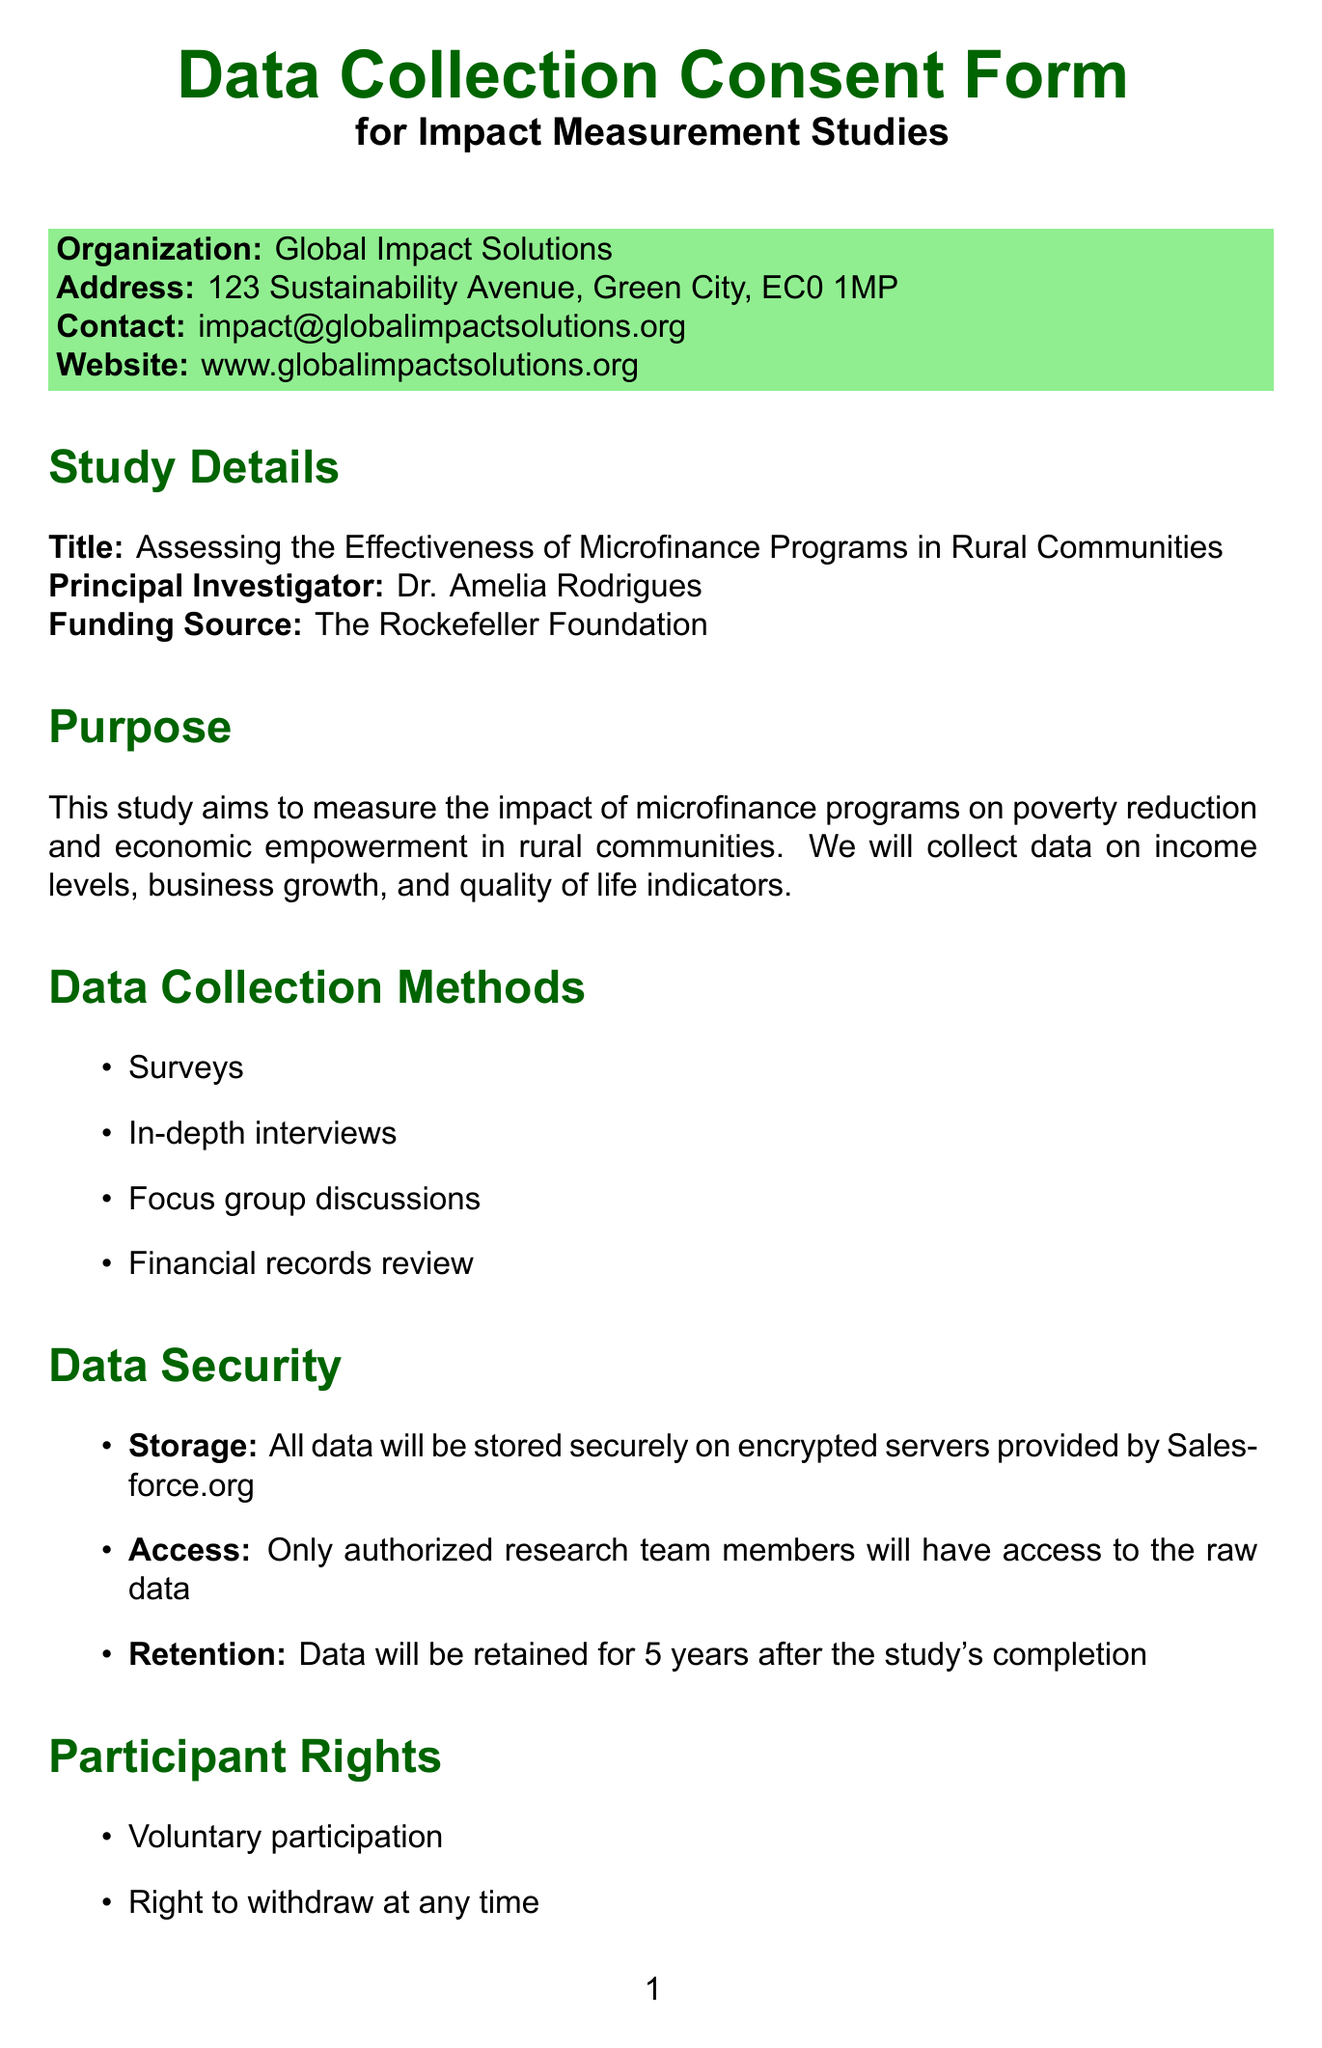what is the title of the study? The title of the study is listed in the document under Study Details.
Answer: Assessing the Effectiveness of Microfinance Programs in Rural Communities who is the principal investigator? The principal investigator is identified in the Study Details section of the document.
Answer: Dr. Amelia Rodrigues how long will data be retained after the study's completion? The data retention period is mentioned under Data Security.
Answer: 5 years what methods will be used for data collection? The data collection methods are specified in a list under Data Collection Methods.
Answer: Surveys, In-depth interviews, Focus group discussions, Financial records review what is the purpose of sharing data with partners? The purpose of data sharing is explained in the Data Sharing section.
Answer: To improve microfinance programs and policies what are participants allowed to do regarding their personal data? Participant rights regarding personal data are listed in the Participant Rights section.
Answer: Access to personal data what risks are involved in participating in the study? The risks associated with participation are described in the Risks and Benefits section.
Answer: Minimal risks involved what is the name of the software used for data collection? The name of the software is specified in the Software Used section.
Answer: ImpactTracker Pro who should participants contact for questions? The contact information for questions is provided at the end of the document.
Answer: Dr. Amelia Rodrigues 